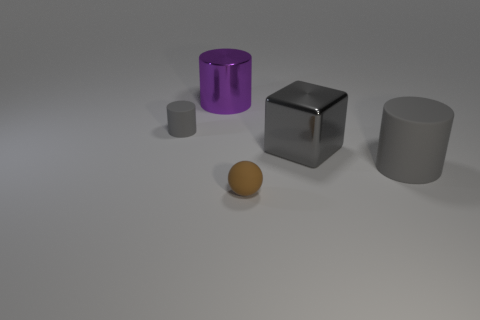Add 4 gray cubes. How many objects exist? 9 Subtract all cylinders. How many objects are left? 2 Subtract all purple metal objects. Subtract all matte cylinders. How many objects are left? 2 Add 1 large gray matte things. How many large gray matte things are left? 2 Add 1 brown objects. How many brown objects exist? 2 Subtract 1 purple cylinders. How many objects are left? 4 